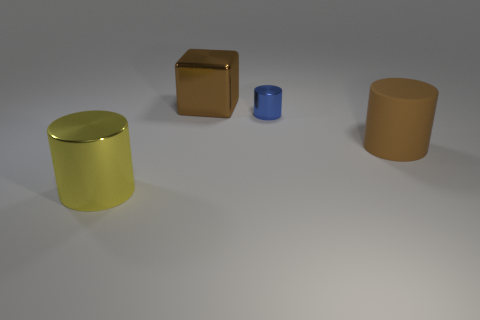Are any tiny cyan shiny cubes visible?
Offer a very short reply. No. How many other objects are the same size as the blue thing?
Provide a short and direct response. 0. Is the color of the large cylinder right of the large brown metallic object the same as the object that is behind the tiny blue metal cylinder?
Make the answer very short. Yes. What size is the yellow object that is the same shape as the tiny blue shiny object?
Provide a succinct answer. Large. Is the material of the big thing that is on the right side of the big shiny block the same as the object that is behind the blue object?
Your response must be concise. No. How many shiny objects are cylinders or small blue cylinders?
Offer a very short reply. 2. What is the material of the brown object to the right of the large metal object behind the metal thing that is in front of the brown matte cylinder?
Provide a succinct answer. Rubber. There is a big thing in front of the big brown rubber cylinder; is its shape the same as the brown thing to the right of the block?
Your answer should be very brief. Yes. There is a big shiny thing in front of the thing that is on the right side of the small blue thing; what is its color?
Ensure brevity in your answer.  Yellow. How many balls are yellow metallic things or tiny blue metallic objects?
Give a very brief answer. 0. 